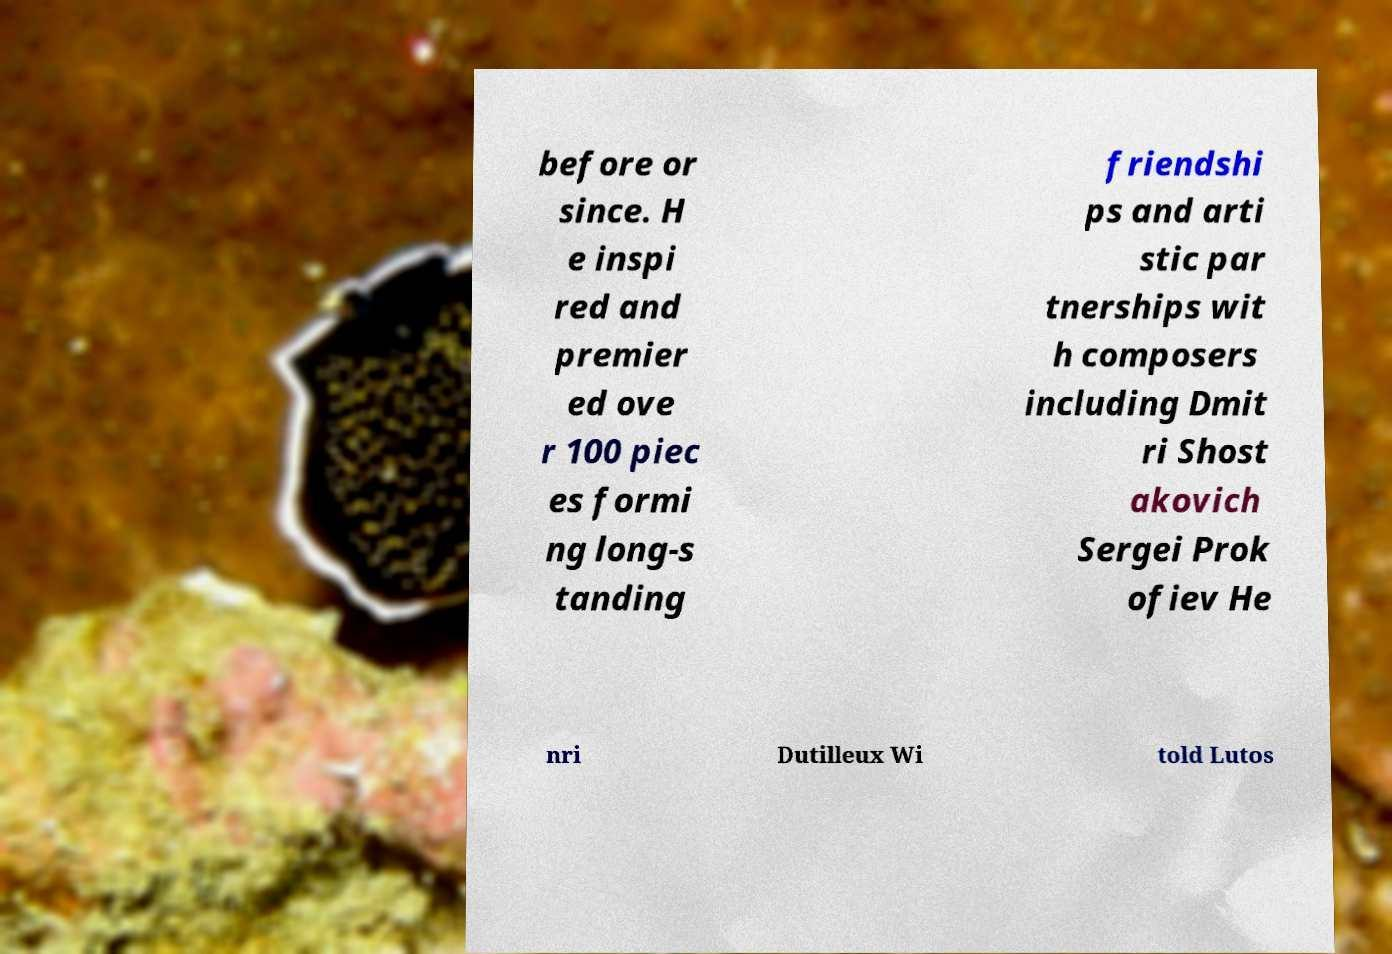Please identify and transcribe the text found in this image. before or since. H e inspi red and premier ed ove r 100 piec es formi ng long-s tanding friendshi ps and arti stic par tnerships wit h composers including Dmit ri Shost akovich Sergei Prok ofiev He nri Dutilleux Wi told Lutos 